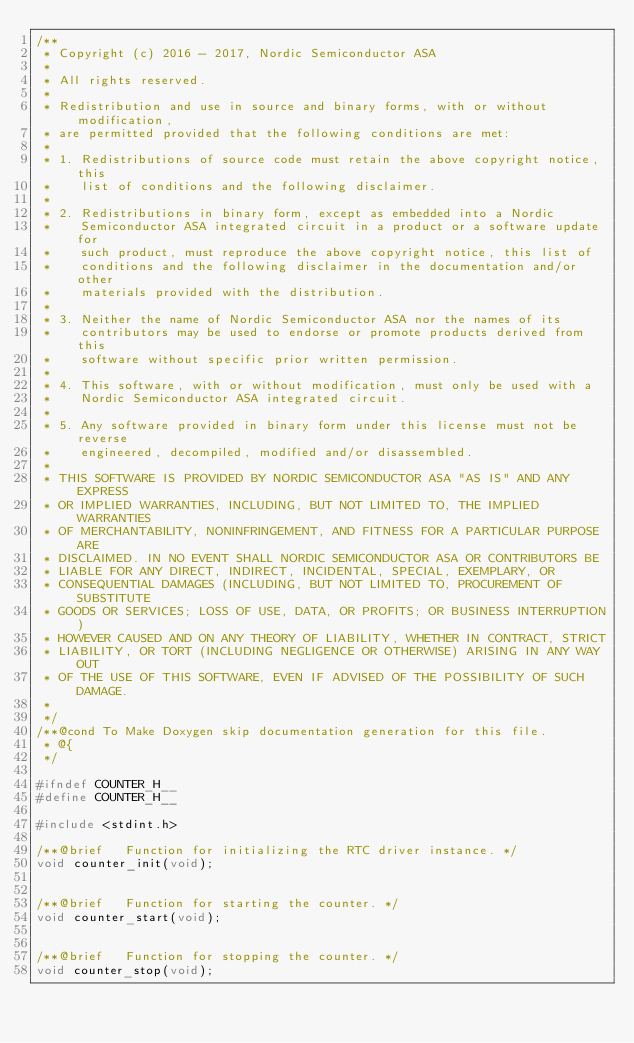Convert code to text. <code><loc_0><loc_0><loc_500><loc_500><_C_>/**
 * Copyright (c) 2016 - 2017, Nordic Semiconductor ASA
 * 
 * All rights reserved.
 * 
 * Redistribution and use in source and binary forms, with or without modification,
 * are permitted provided that the following conditions are met:
 * 
 * 1. Redistributions of source code must retain the above copyright notice, this
 *    list of conditions and the following disclaimer.
 * 
 * 2. Redistributions in binary form, except as embedded into a Nordic
 *    Semiconductor ASA integrated circuit in a product or a software update for
 *    such product, must reproduce the above copyright notice, this list of
 *    conditions and the following disclaimer in the documentation and/or other
 *    materials provided with the distribution.
 * 
 * 3. Neither the name of Nordic Semiconductor ASA nor the names of its
 *    contributors may be used to endorse or promote products derived from this
 *    software without specific prior written permission.
 * 
 * 4. This software, with or without modification, must only be used with a
 *    Nordic Semiconductor ASA integrated circuit.
 * 
 * 5. Any software provided in binary form under this license must not be reverse
 *    engineered, decompiled, modified and/or disassembled.
 * 
 * THIS SOFTWARE IS PROVIDED BY NORDIC SEMICONDUCTOR ASA "AS IS" AND ANY EXPRESS
 * OR IMPLIED WARRANTIES, INCLUDING, BUT NOT LIMITED TO, THE IMPLIED WARRANTIES
 * OF MERCHANTABILITY, NONINFRINGEMENT, AND FITNESS FOR A PARTICULAR PURPOSE ARE
 * DISCLAIMED. IN NO EVENT SHALL NORDIC SEMICONDUCTOR ASA OR CONTRIBUTORS BE
 * LIABLE FOR ANY DIRECT, INDIRECT, INCIDENTAL, SPECIAL, EXEMPLARY, OR
 * CONSEQUENTIAL DAMAGES (INCLUDING, BUT NOT LIMITED TO, PROCUREMENT OF SUBSTITUTE
 * GOODS OR SERVICES; LOSS OF USE, DATA, OR PROFITS; OR BUSINESS INTERRUPTION)
 * HOWEVER CAUSED AND ON ANY THEORY OF LIABILITY, WHETHER IN CONTRACT, STRICT
 * LIABILITY, OR TORT (INCLUDING NEGLIGENCE OR OTHERWISE) ARISING IN ANY WAY OUT
 * OF THE USE OF THIS SOFTWARE, EVEN IF ADVISED OF THE POSSIBILITY OF SUCH DAMAGE.
 * 
 */
/**@cond To Make Doxygen skip documentation generation for this file.
 * @{
 */

#ifndef COUNTER_H__
#define COUNTER_H__

#include <stdint.h>

/**@brief   Function for initializing the RTC driver instance. */
void counter_init(void);


/**@brief   Function for starting the counter. */
void counter_start(void);


/**@brief   Function for stopping the counter. */
void counter_stop(void);

</code> 